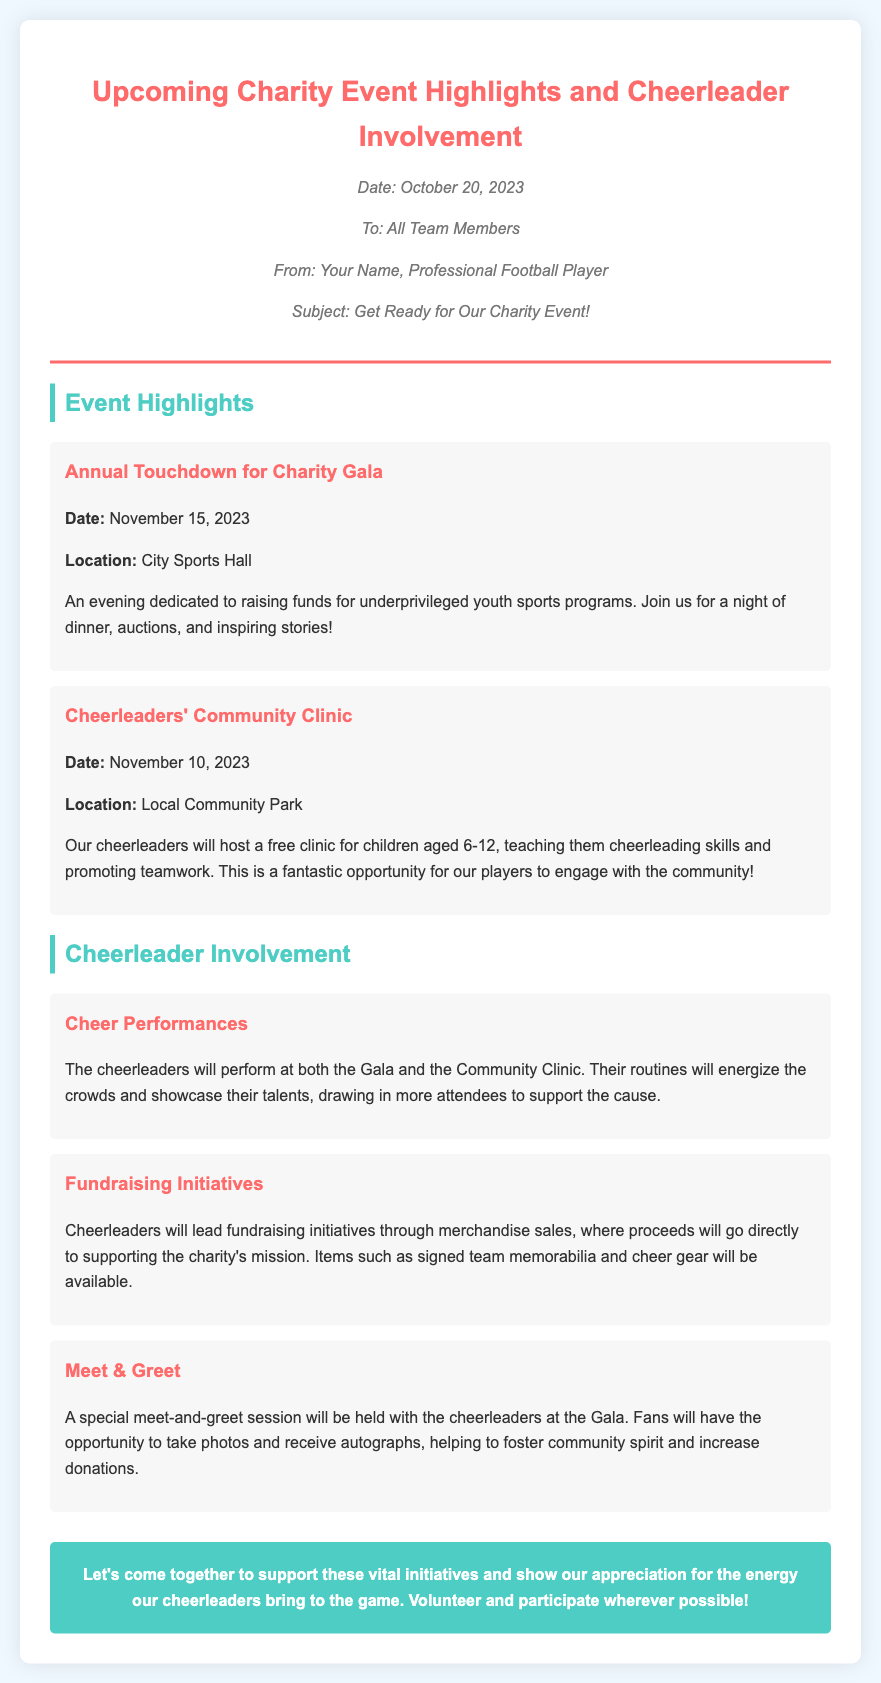What is the date of the Annual Touchdown for Charity Gala? The document specifies that the Annual Touchdown for Charity Gala is on November 15, 2023.
Answer: November 15, 2023 Where is the Community Clinic taking place? According to the memo, the Community Clinic will be held at Local Community Park.
Answer: Local Community Park What age group will the cheerleaders' Community Clinic cater to? The memo states that the Community Clinic is for children aged 6-12.
Answer: 6-12 What type of performances will the cheerleaders do at the events? The document mentions that the cheerleaders will perform at both the Gala and the Community Clinic.
Answer: Performances What items will be available for sale during the fundraising initiatives? The document lists signed team memorabilia and cheer gear as available merchandise.
Answer: Signed team memorabilia and cheer gear Which event includes a Meet & Greet session with cheerleaders? The memo indicates that the Meet & Greet session will occur at the Gala.
Answer: Gala What is the primary goal of the Annual Touchdown for Charity Gala? The memo emphasizes that the goal is to raise funds for underprivileged youth sports programs.
Answer: Raise funds for underprivileged youth sports programs How are the cheerleaders expected to contribute to community engagement? The document highlights that cheerleaders will host a free clinic and participate in fundraising initiatives.
Answer: Host a free clinic and participate in fundraising initiatives 